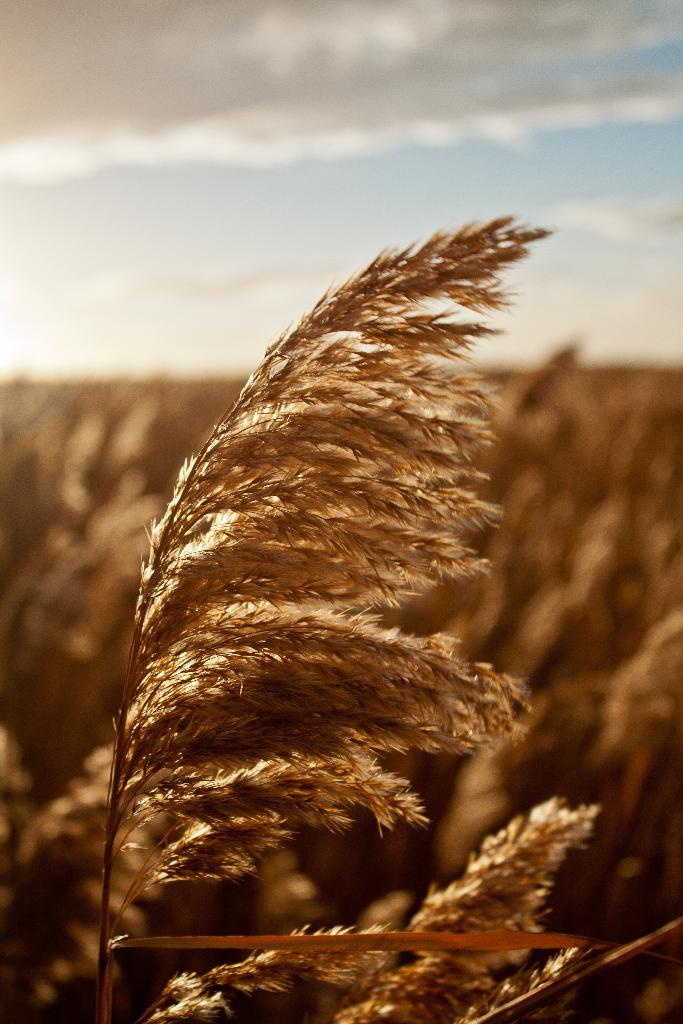What type of living organism can be seen in the image? There is a plant in the image, and there are multiple plants in the image. What can be seen in the background of the image? The sky is visible in the background of the image. What is the condition of the sky in the image? Clouds are present in the sky. Is the plant in the image growing in a cellar? There is no information provided about the location or environment where the plant is growing, so it cannot be determined if it is in a cellar or not. 